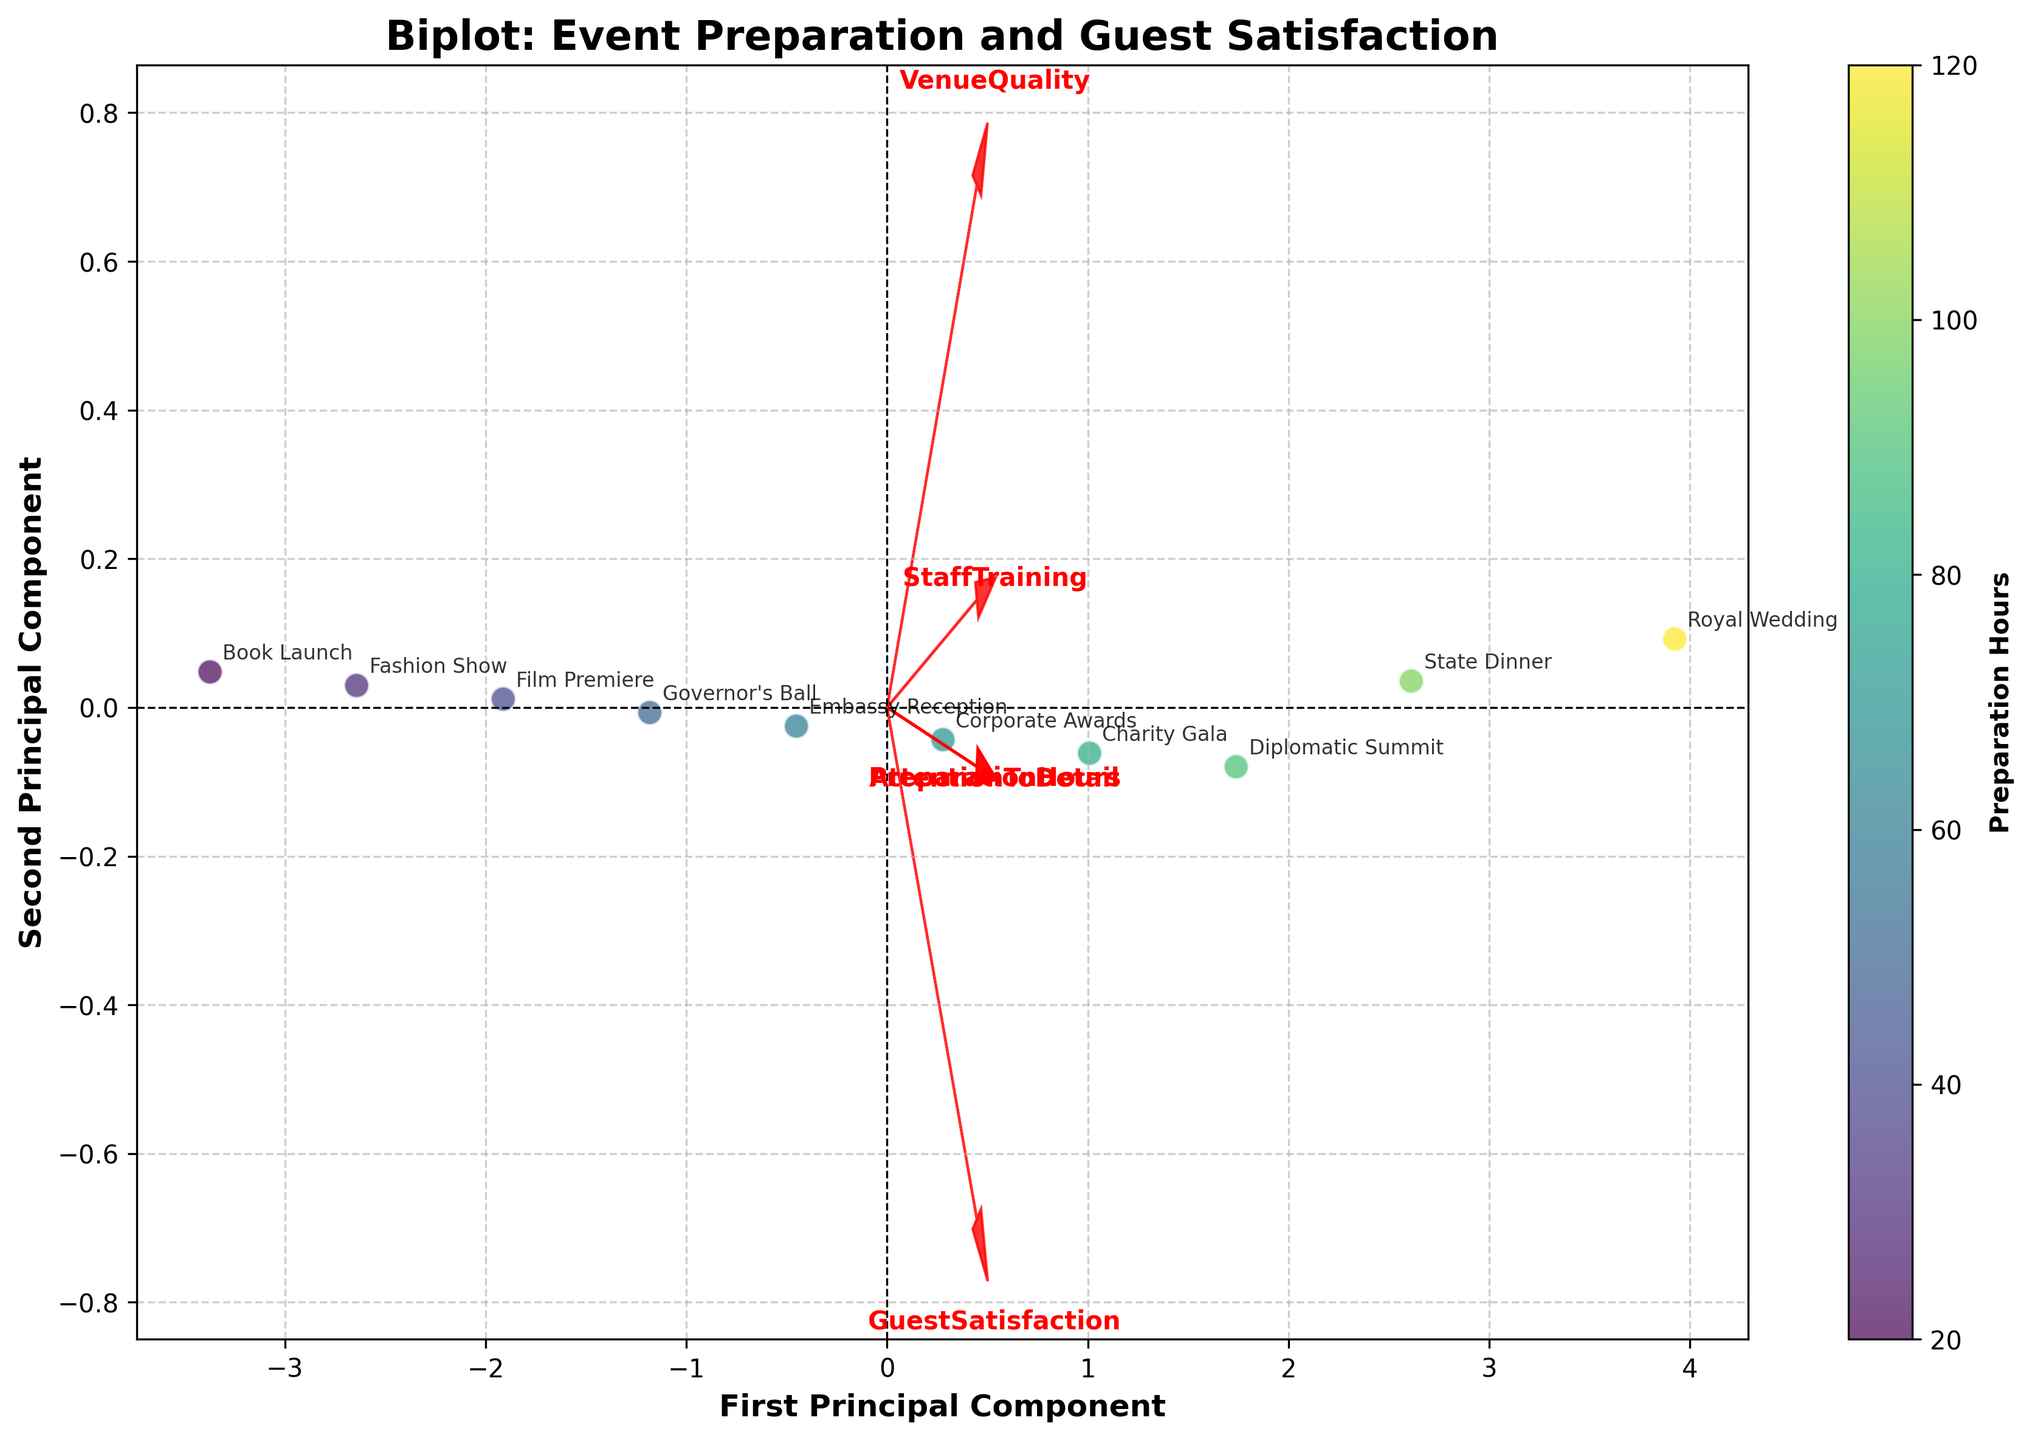Which type of events are represented in the plot? The plot is titled "Biplot: Event Preparation and Guest Satisfaction," and each data point is labeled with an event name (e.g., Royal Wedding, State Dinner).
Answer: High-profile social gatherings and official ceremonies What does the color of the data points represent? The color of the data points varies and is related to the number of "Preparation Hours," as indicated by the color bar.
Answer: Preparation Hours Which axis represents the first and second principal components? The first principal component is represented by the horizontal axis, and the second principal component is represented by the vertical axis. This is indicated by the axis labels "First Principal Component" and "Second Principal Component."
Answer: Horizontal: First Principal Component; Vertical: Second Principal Component Which event had the highest preparation hours? By looking at the color gradient and the labeled data points, the "Royal Wedding" is the most prominent yellow point, indicating the highest preparation hours.
Answer: Royal Wedding How are "Guest Satisfaction" and "Preparation Hours" related based on the plot? The arrows for "Guest Satisfaction" and "Preparation Hours" seem to point in similar directions, suggesting a positive correlation, meaning as preparation hours increase, guest satisfaction also tends to increase.
Answer: Positively correlated Which feature has the smallest impact on the first principal component? Looking at the lengths of the arrows for the features on the first principal component (horizontal), "StaffTraining" has the smallest contribution because its arrow is the shortest along this direction.
Answer: Staff Training What can be inferred about the event with the lowest guest satisfaction rating? The "Book Launch" appears on the lower end of the Guest Satisfaction arrow, indicating the lowest rating among the events represented.
Answer: Book Launch Which events have similar principal component scores based on the plot? The "Diplomatic Summit" and "Charity Gala" are located close together in the principal component space, suggesting they have similar scores.
Answer: Diplomatic Summit and Charity Gala What does the direction of the 'AttentionToDetail' vector suggest about its relationship with other variables? The "AttentionToDetail" vector points in a similar direction as "GuestSatisfaction" and "PreparationHours," suggesting positive correlations with these variables.
Answer: Positive correlations with Guest Satisfaction and Preparation Hours Which variable has the strongest influence on the second principal component? The "VenueQuality" arrow extends the furthest along the vertical axis (second principal component), indicating it has the strongest influence.
Answer: Venue Quality How does the preparation time for "Corporate Awards" compare with "Governor's Ball"? The color of the data point for "Corporate Awards" is more saturated compared to the "Governor's Ball," indicating that "Corporate Awards" has higher preparation hours.
Answer: Corporate Awards has higher preparation hours 